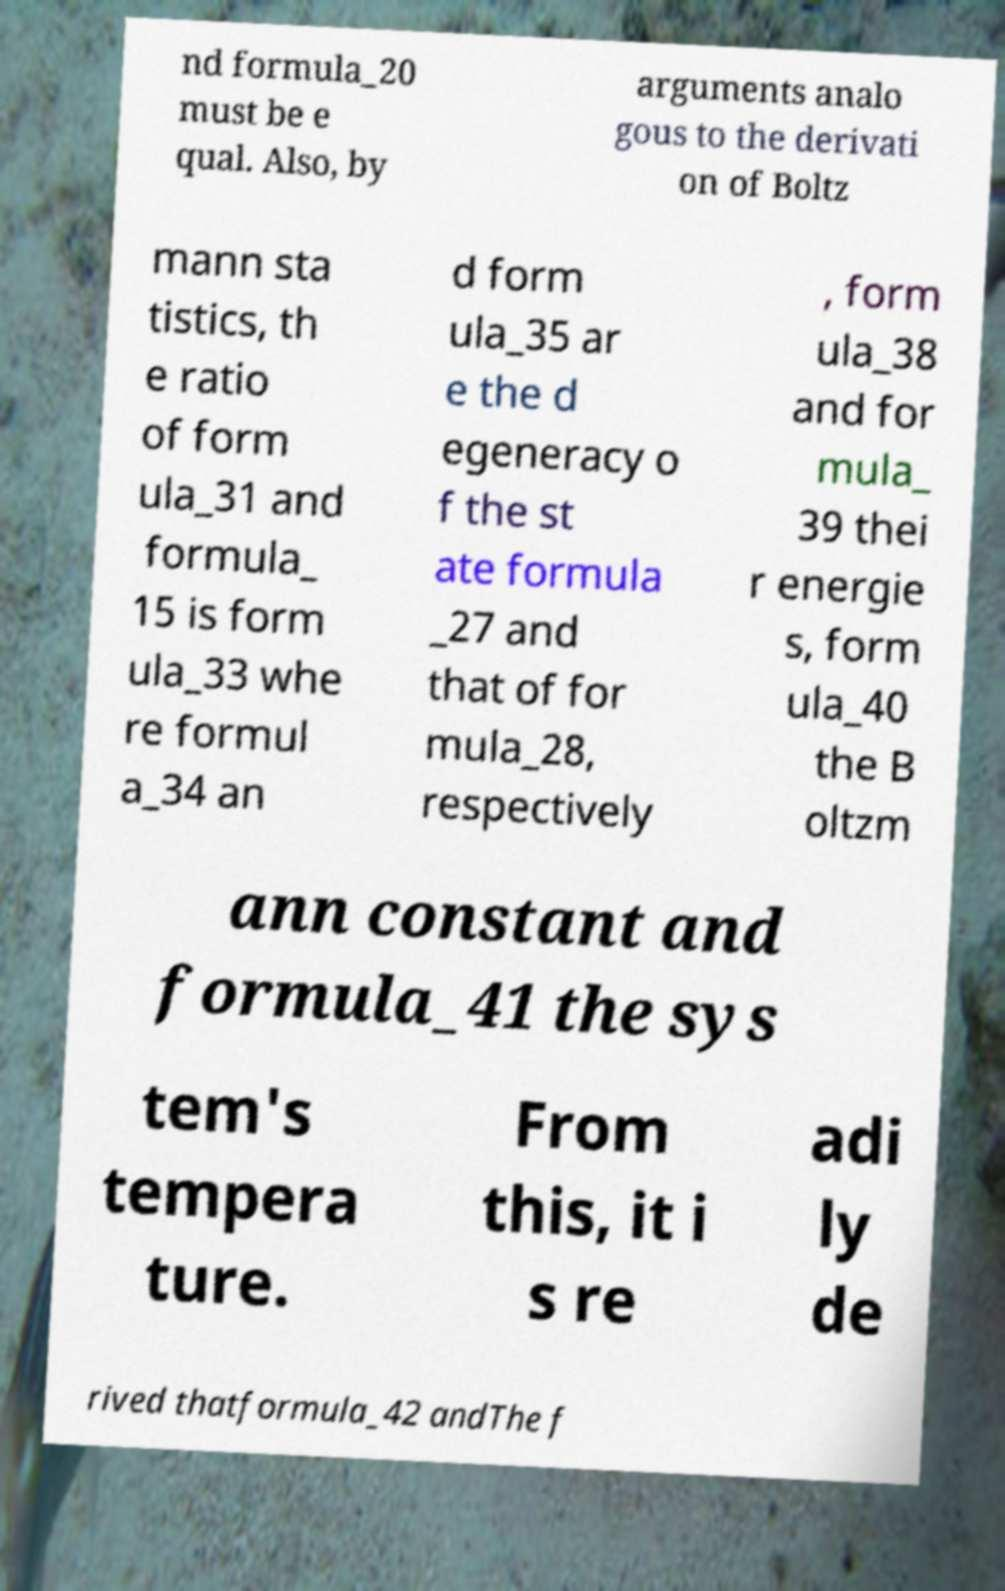Can you read and provide the text displayed in the image?This photo seems to have some interesting text. Can you extract and type it out for me? nd formula_20 must be e qual. Also, by arguments analo gous to the derivati on of Boltz mann sta tistics, th e ratio of form ula_31 and formula_ 15 is form ula_33 whe re formul a_34 an d form ula_35 ar e the d egeneracy o f the st ate formula _27 and that of for mula_28, respectively , form ula_38 and for mula_ 39 thei r energie s, form ula_40 the B oltzm ann constant and formula_41 the sys tem's tempera ture. From this, it i s re adi ly de rived thatformula_42 andThe f 